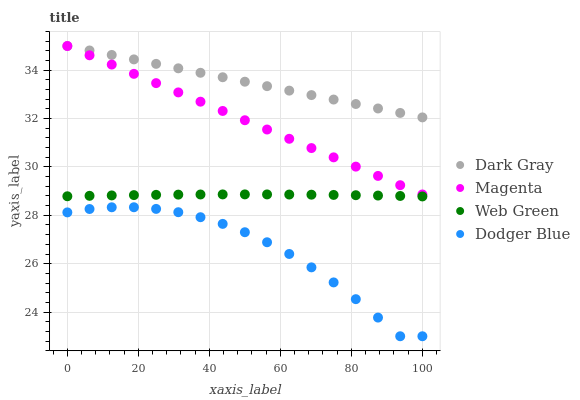Does Dodger Blue have the minimum area under the curve?
Answer yes or no. Yes. Does Dark Gray have the maximum area under the curve?
Answer yes or no. Yes. Does Magenta have the minimum area under the curve?
Answer yes or no. No. Does Magenta have the maximum area under the curve?
Answer yes or no. No. Is Magenta the smoothest?
Answer yes or no. Yes. Is Dodger Blue the roughest?
Answer yes or no. Yes. Is Dodger Blue the smoothest?
Answer yes or no. No. Is Magenta the roughest?
Answer yes or no. No. Does Dodger Blue have the lowest value?
Answer yes or no. Yes. Does Magenta have the lowest value?
Answer yes or no. No. Does Magenta have the highest value?
Answer yes or no. Yes. Does Dodger Blue have the highest value?
Answer yes or no. No. Is Dodger Blue less than Dark Gray?
Answer yes or no. Yes. Is Dark Gray greater than Dodger Blue?
Answer yes or no. Yes. Does Magenta intersect Dark Gray?
Answer yes or no. Yes. Is Magenta less than Dark Gray?
Answer yes or no. No. Is Magenta greater than Dark Gray?
Answer yes or no. No. Does Dodger Blue intersect Dark Gray?
Answer yes or no. No. 